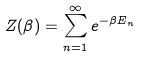Convert formula to latex. <formula><loc_0><loc_0><loc_500><loc_500>Z ( \beta ) = \sum _ { n = 1 } ^ { \infty } e ^ { - \beta E _ { n } }</formula> 